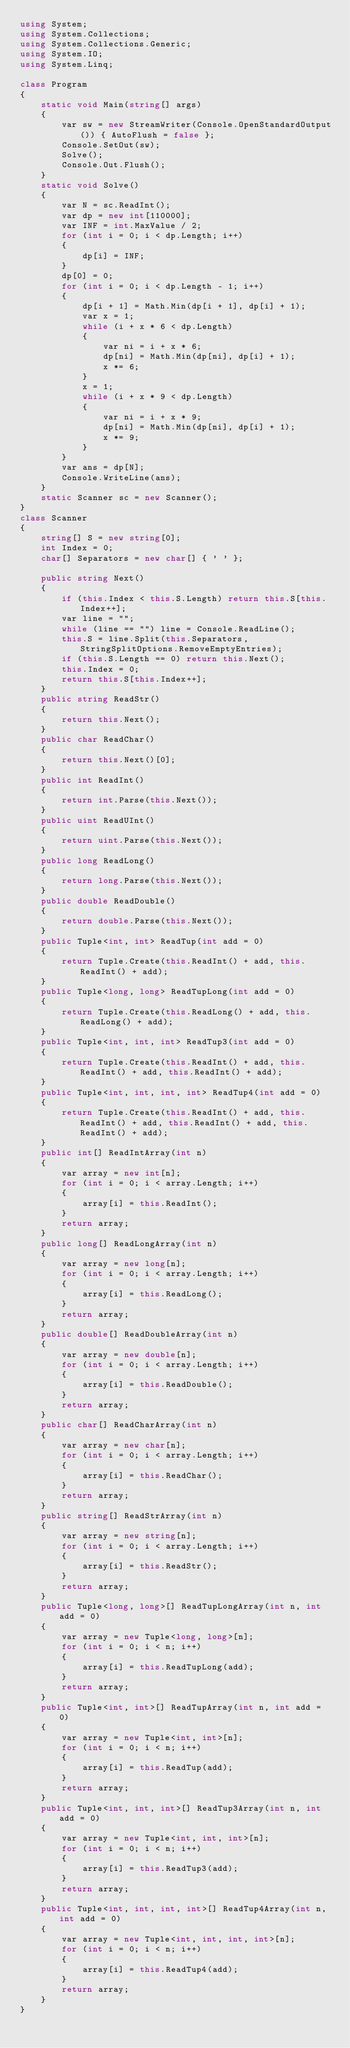Convert code to text. <code><loc_0><loc_0><loc_500><loc_500><_C#_>using System;
using System.Collections;
using System.Collections.Generic;
using System.IO;
using System.Linq;

class Program
{
    static void Main(string[] args)
    {
        var sw = new StreamWriter(Console.OpenStandardOutput()) { AutoFlush = false };
        Console.SetOut(sw);
        Solve();
        Console.Out.Flush();
    }
    static void Solve()
    {
        var N = sc.ReadInt();
        var dp = new int[110000];
        var INF = int.MaxValue / 2;
        for (int i = 0; i < dp.Length; i++)
        {
            dp[i] = INF;
        }
        dp[0] = 0;
        for (int i = 0; i < dp.Length - 1; i++)
        {
            dp[i + 1] = Math.Min(dp[i + 1], dp[i] + 1);
            var x = 1;
            while (i + x * 6 < dp.Length)
            {
                var ni = i + x * 6;
                dp[ni] = Math.Min(dp[ni], dp[i] + 1);
                x *= 6;
            }
            x = 1;
            while (i + x * 9 < dp.Length)
            {
                var ni = i + x * 9;
                dp[ni] = Math.Min(dp[ni], dp[i] + 1);
                x *= 9;
            }
        }
        var ans = dp[N];
        Console.WriteLine(ans);
    }
    static Scanner sc = new Scanner();
}
class Scanner
{
    string[] S = new string[0];
    int Index = 0;
    char[] Separators = new char[] { ' ' };

    public string Next()
    {
        if (this.Index < this.S.Length) return this.S[this.Index++];
        var line = "";
        while (line == "") line = Console.ReadLine();
        this.S = line.Split(this.Separators, StringSplitOptions.RemoveEmptyEntries);
        if (this.S.Length == 0) return this.Next();
        this.Index = 0;
        return this.S[this.Index++];
    }
    public string ReadStr()
    {
        return this.Next();
    }
    public char ReadChar()
    {
        return this.Next()[0];
    }
    public int ReadInt()
    {
        return int.Parse(this.Next());
    }
    public uint ReadUInt()
    {
        return uint.Parse(this.Next());
    }
    public long ReadLong()
    {
        return long.Parse(this.Next());
    }
    public double ReadDouble()
    {
        return double.Parse(this.Next());
    }
    public Tuple<int, int> ReadTup(int add = 0)
    {
        return Tuple.Create(this.ReadInt() + add, this.ReadInt() + add);
    }
    public Tuple<long, long> ReadTupLong(int add = 0)
    {
        return Tuple.Create(this.ReadLong() + add, this.ReadLong() + add);
    }
    public Tuple<int, int, int> ReadTup3(int add = 0)
    {
        return Tuple.Create(this.ReadInt() + add, this.ReadInt() + add, this.ReadInt() + add);
    }
    public Tuple<int, int, int, int> ReadTup4(int add = 0)
    {
        return Tuple.Create(this.ReadInt() + add, this.ReadInt() + add, this.ReadInt() + add, this.ReadInt() + add);
    }
    public int[] ReadIntArray(int n)
    {
        var array = new int[n];
        for (int i = 0; i < array.Length; i++)
        {
            array[i] = this.ReadInt();
        }
        return array;
    }
    public long[] ReadLongArray(int n)
    {
        var array = new long[n];
        for (int i = 0; i < array.Length; i++)
        {
            array[i] = this.ReadLong();
        }
        return array;
    }
    public double[] ReadDoubleArray(int n)
    {
        var array = new double[n];
        for (int i = 0; i < array.Length; i++)
        {
            array[i] = this.ReadDouble();
        }
        return array;
    }
    public char[] ReadCharArray(int n)
    {
        var array = new char[n];
        for (int i = 0; i < array.Length; i++)
        {
            array[i] = this.ReadChar();
        }
        return array;
    }
    public string[] ReadStrArray(int n)
    {
        var array = new string[n];
        for (int i = 0; i < array.Length; i++)
        {
            array[i] = this.ReadStr();
        }
        return array;
    }
    public Tuple<long, long>[] ReadTupLongArray(int n, int add = 0)
    {
        var array = new Tuple<long, long>[n];
        for (int i = 0; i < n; i++)
        {
            array[i] = this.ReadTupLong(add);
        }
        return array;
    }
    public Tuple<int, int>[] ReadTupArray(int n, int add = 0)
    {
        var array = new Tuple<int, int>[n];
        for (int i = 0; i < n; i++)
        {
            array[i] = this.ReadTup(add);
        }
        return array;
    }
    public Tuple<int, int, int>[] ReadTup3Array(int n, int add = 0)
    {
        var array = new Tuple<int, int, int>[n];
        for (int i = 0; i < n; i++)
        {
            array[i] = this.ReadTup3(add);
        }
        return array;
    }
    public Tuple<int, int, int, int>[] ReadTup4Array(int n, int add = 0)
    {
        var array = new Tuple<int, int, int, int>[n];
        for (int i = 0; i < n; i++)
        {
            array[i] = this.ReadTup4(add);
        }
        return array;
    }
}
</code> 